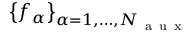Convert formula to latex. <formula><loc_0><loc_0><loc_500><loc_500>\left \{ f _ { \alpha } \right \} _ { \alpha = 1 , \dots , N _ { a u x } }</formula> 